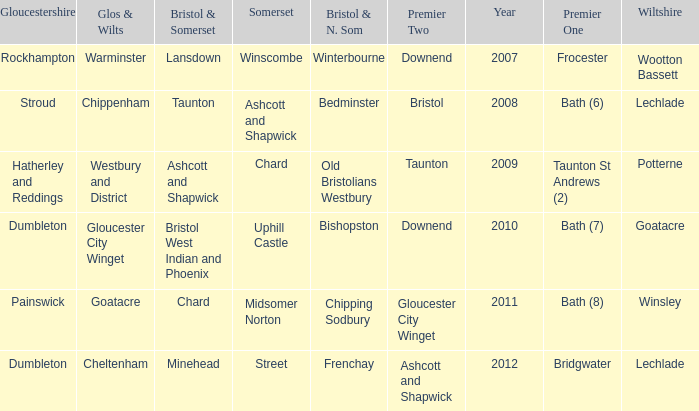Who many times is gloucestershire is painswick? 1.0. 